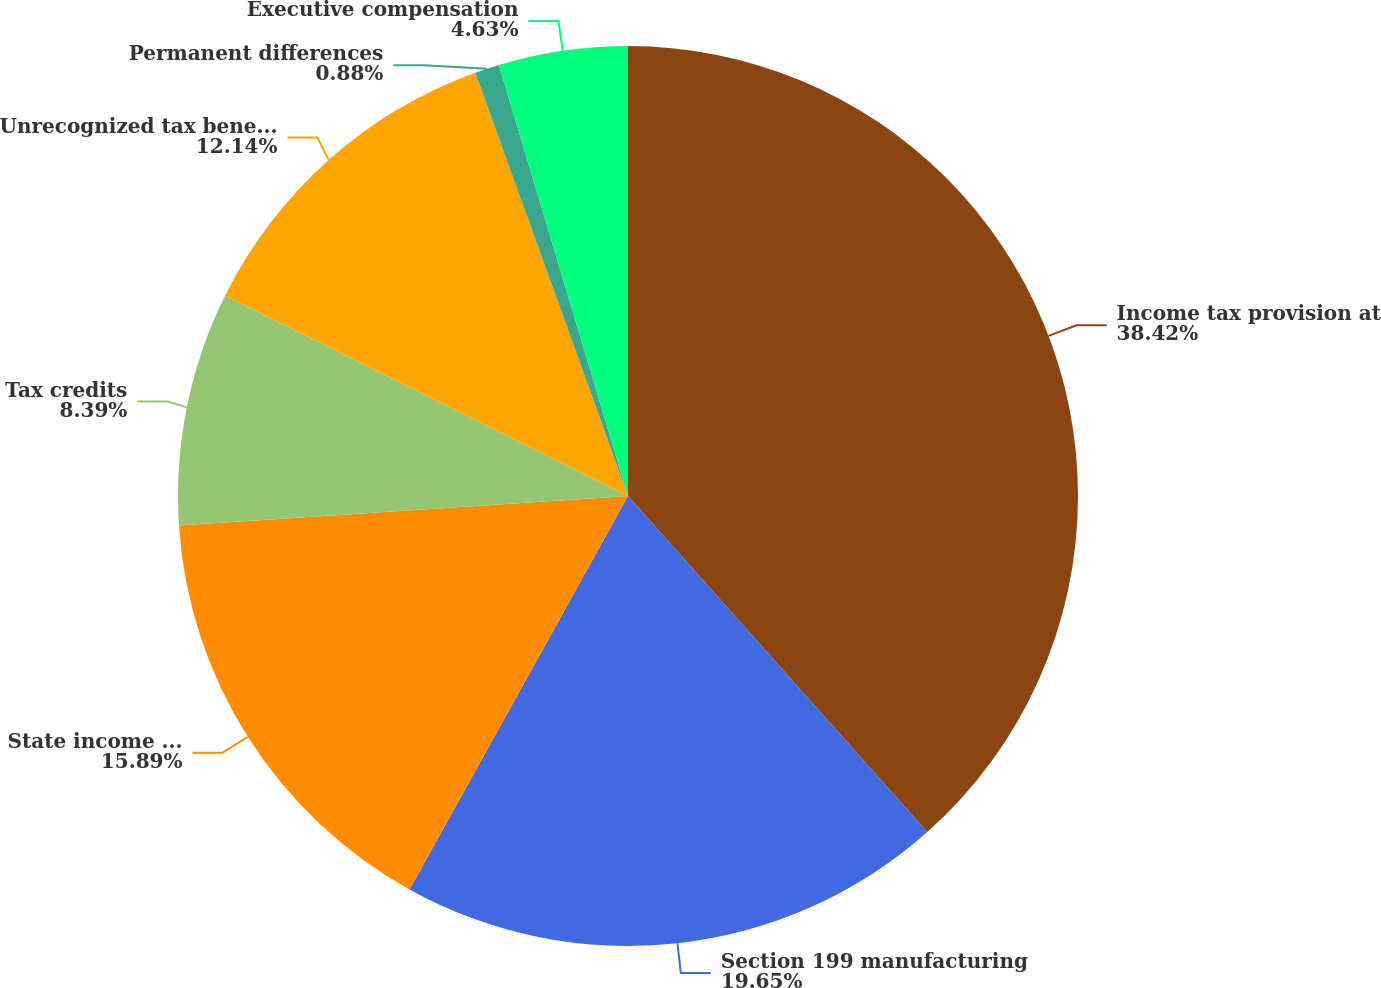Convert chart. <chart><loc_0><loc_0><loc_500><loc_500><pie_chart><fcel>Income tax provision at<fcel>Section 199 manufacturing<fcel>State income taxes net of<fcel>Tax credits<fcel>Unrecognized tax benefits<fcel>Permanent differences<fcel>Executive compensation<nl><fcel>38.42%<fcel>19.65%<fcel>15.89%<fcel>8.39%<fcel>12.14%<fcel>0.88%<fcel>4.63%<nl></chart> 